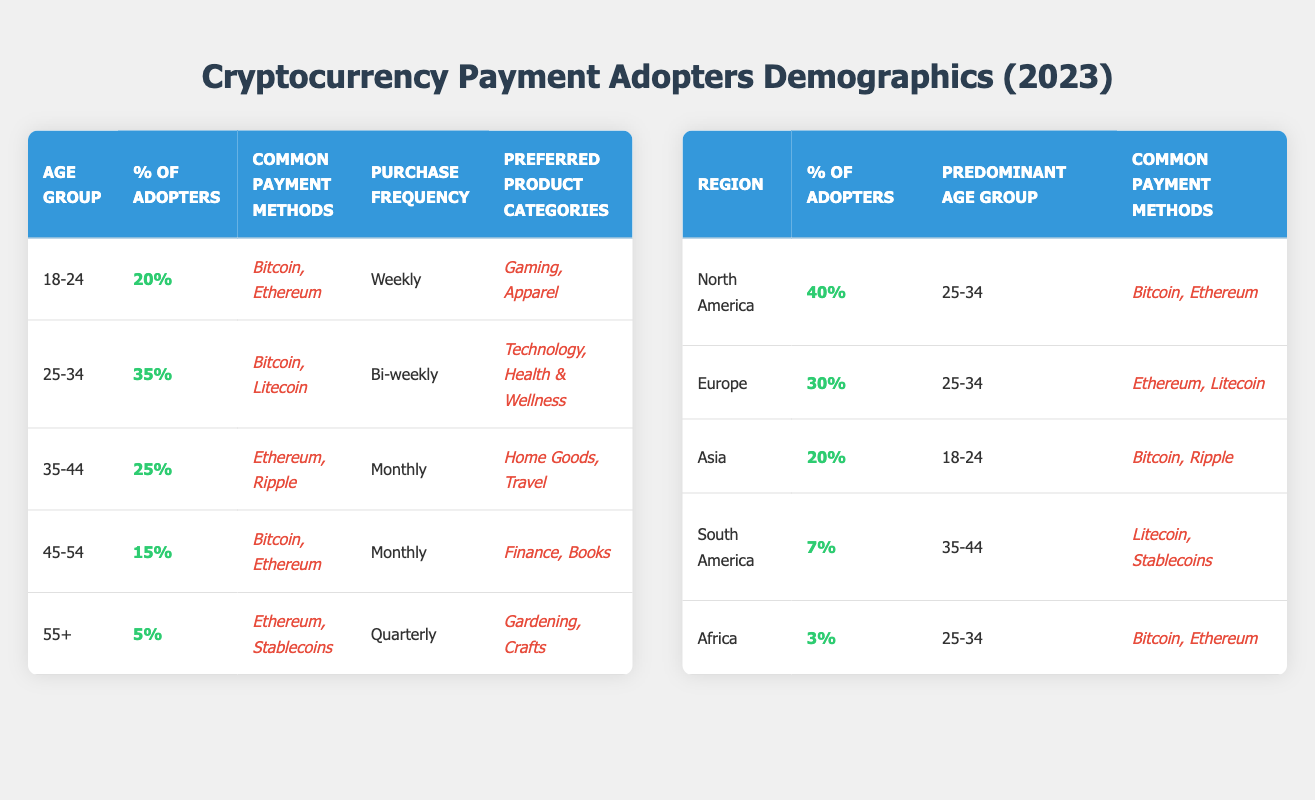What is the percentage of cryptocurrency payment adopters in the 25-34 age group? By looking at the table, under the age demographics section, the percentage of adopters for the age group 25-34 is specifically listed as 35%.
Answer: 35% Which common payment method is most frequently used by the 18-24 age group? In the table, the common payment methods for the 18-24 age group are Bitcoin and Ethereum. Both are listed, but no single payment method is emphasized more than the other in this category.
Answer: Bitcoin and Ethereum How many times per month does the 45-54 age group typically make purchases? According to the purchase frequency in the table, the 45-54 age group is noted to make purchases monthly.
Answer: Monthly What is the predominant age group for cryptocurrency adopters in North America? The table indicates that in North America, the predominant age group for cryptocurrency payment adopters is 25-34 years old.
Answer: 25-34 Which region has the highest percentage of cryptocurrency payment adopters? The percentage of adopters for each region shows North America with the highest percentage at 40%.
Answer: North America Is Ethereum one of the common payment methods used by the 55+ age group? Yes, according to the common payment methods listed in the table for the 55+ age group, Ethereum is mentioned as one of the payment options.
Answer: Yes What is the average percentage of cryptocurrency payment adopters across all age groups? To find the average, sum the percentages (20 + 35 + 25 + 15 + 5 = 100) and divide by the number of age groups (5). The average percentage is 100/5 = 20%.
Answer: 20% In which region do cryptocurrency adoption rates show the least percentage? The table indicates that Africa has the lowest adoption rate at 3%, compared to other regions.
Answer: Africa What are the preferred product categories for the 35-44 age group? The table lists the preferred product categories for the 35-44 age group as Home Goods and Travel.
Answer: Home Goods, Travel 